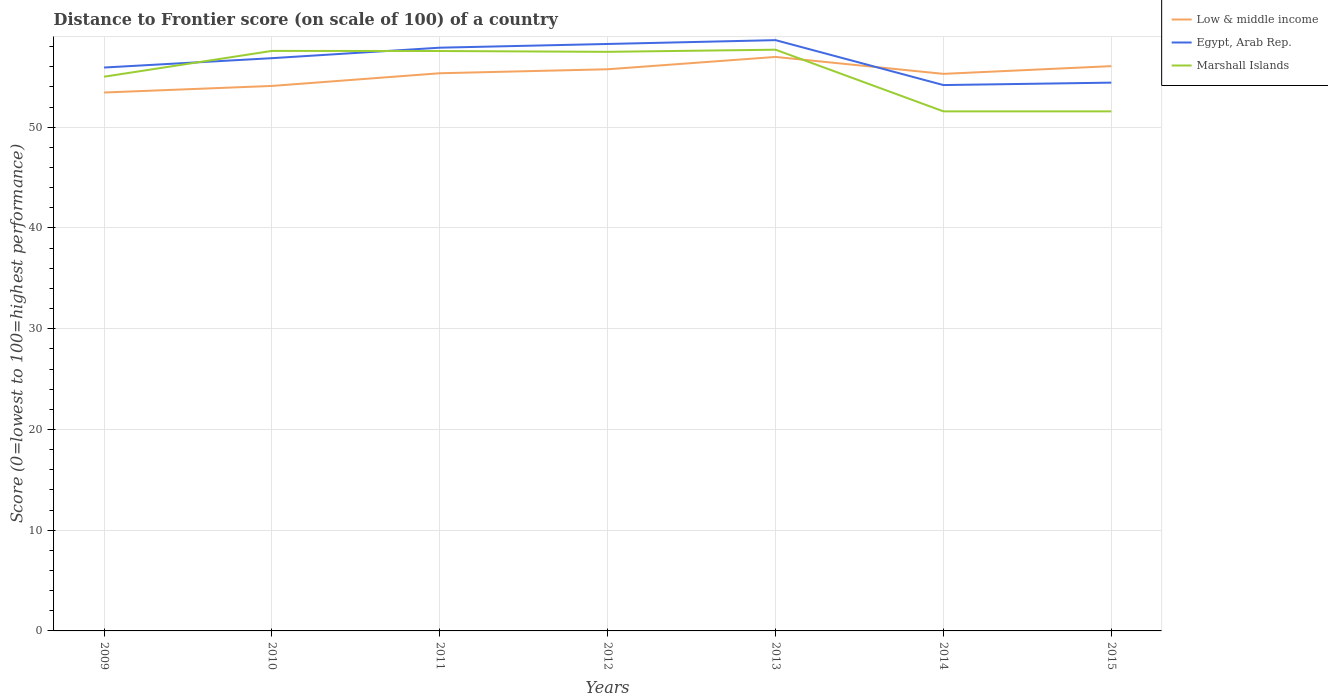Does the line corresponding to Marshall Islands intersect with the line corresponding to Low & middle income?
Keep it short and to the point. Yes. Is the number of lines equal to the number of legend labels?
Ensure brevity in your answer.  Yes. Across all years, what is the maximum distance to frontier score of in Marshall Islands?
Your response must be concise. 51.58. What is the difference between the highest and the second highest distance to frontier score of in Egypt, Arab Rep.?
Keep it short and to the point. 4.46. What is the difference between the highest and the lowest distance to frontier score of in Low & middle income?
Keep it short and to the point. 5. How many lines are there?
Provide a short and direct response. 3. What is the difference between two consecutive major ticks on the Y-axis?
Give a very brief answer. 10. Are the values on the major ticks of Y-axis written in scientific E-notation?
Your answer should be compact. No. Does the graph contain grids?
Ensure brevity in your answer.  Yes. How many legend labels are there?
Your response must be concise. 3. How are the legend labels stacked?
Your answer should be compact. Vertical. What is the title of the graph?
Offer a very short reply. Distance to Frontier score (on scale of 100) of a country. Does "Other small states" appear as one of the legend labels in the graph?
Offer a terse response. No. What is the label or title of the X-axis?
Give a very brief answer. Years. What is the label or title of the Y-axis?
Offer a very short reply. Score (0=lowest to 100=highest performance). What is the Score (0=lowest to 100=highest performance) in Low & middle income in 2009?
Ensure brevity in your answer.  53.45. What is the Score (0=lowest to 100=highest performance) of Egypt, Arab Rep. in 2009?
Your answer should be compact. 55.93. What is the Score (0=lowest to 100=highest performance) of Marshall Islands in 2009?
Ensure brevity in your answer.  55.02. What is the Score (0=lowest to 100=highest performance) of Low & middle income in 2010?
Your answer should be compact. 54.1. What is the Score (0=lowest to 100=highest performance) of Egypt, Arab Rep. in 2010?
Offer a terse response. 56.86. What is the Score (0=lowest to 100=highest performance) in Marshall Islands in 2010?
Offer a very short reply. 57.58. What is the Score (0=lowest to 100=highest performance) of Low & middle income in 2011?
Give a very brief answer. 55.36. What is the Score (0=lowest to 100=highest performance) in Egypt, Arab Rep. in 2011?
Make the answer very short. 57.9. What is the Score (0=lowest to 100=highest performance) in Marshall Islands in 2011?
Ensure brevity in your answer.  57.57. What is the Score (0=lowest to 100=highest performance) in Low & middle income in 2012?
Your response must be concise. 55.76. What is the Score (0=lowest to 100=highest performance) of Egypt, Arab Rep. in 2012?
Ensure brevity in your answer.  58.27. What is the Score (0=lowest to 100=highest performance) of Marshall Islands in 2012?
Offer a very short reply. 57.49. What is the Score (0=lowest to 100=highest performance) in Low & middle income in 2013?
Your answer should be compact. 56.98. What is the Score (0=lowest to 100=highest performance) of Egypt, Arab Rep. in 2013?
Offer a terse response. 58.65. What is the Score (0=lowest to 100=highest performance) in Marshall Islands in 2013?
Give a very brief answer. 57.7. What is the Score (0=lowest to 100=highest performance) in Low & middle income in 2014?
Your answer should be very brief. 55.3. What is the Score (0=lowest to 100=highest performance) in Egypt, Arab Rep. in 2014?
Provide a short and direct response. 54.19. What is the Score (0=lowest to 100=highest performance) of Marshall Islands in 2014?
Offer a terse response. 51.58. What is the Score (0=lowest to 100=highest performance) of Low & middle income in 2015?
Make the answer very short. 56.07. What is the Score (0=lowest to 100=highest performance) of Egypt, Arab Rep. in 2015?
Your answer should be compact. 54.43. What is the Score (0=lowest to 100=highest performance) in Marshall Islands in 2015?
Ensure brevity in your answer.  51.58. Across all years, what is the maximum Score (0=lowest to 100=highest performance) of Low & middle income?
Offer a terse response. 56.98. Across all years, what is the maximum Score (0=lowest to 100=highest performance) in Egypt, Arab Rep.?
Your response must be concise. 58.65. Across all years, what is the maximum Score (0=lowest to 100=highest performance) of Marshall Islands?
Make the answer very short. 57.7. Across all years, what is the minimum Score (0=lowest to 100=highest performance) of Low & middle income?
Keep it short and to the point. 53.45. Across all years, what is the minimum Score (0=lowest to 100=highest performance) in Egypt, Arab Rep.?
Make the answer very short. 54.19. Across all years, what is the minimum Score (0=lowest to 100=highest performance) in Marshall Islands?
Your answer should be very brief. 51.58. What is the total Score (0=lowest to 100=highest performance) in Low & middle income in the graph?
Give a very brief answer. 387.03. What is the total Score (0=lowest to 100=highest performance) in Egypt, Arab Rep. in the graph?
Your answer should be compact. 396.23. What is the total Score (0=lowest to 100=highest performance) of Marshall Islands in the graph?
Provide a short and direct response. 388.52. What is the difference between the Score (0=lowest to 100=highest performance) of Low & middle income in 2009 and that in 2010?
Make the answer very short. -0.65. What is the difference between the Score (0=lowest to 100=highest performance) of Egypt, Arab Rep. in 2009 and that in 2010?
Provide a succinct answer. -0.93. What is the difference between the Score (0=lowest to 100=highest performance) of Marshall Islands in 2009 and that in 2010?
Make the answer very short. -2.56. What is the difference between the Score (0=lowest to 100=highest performance) in Low & middle income in 2009 and that in 2011?
Give a very brief answer. -1.91. What is the difference between the Score (0=lowest to 100=highest performance) in Egypt, Arab Rep. in 2009 and that in 2011?
Offer a terse response. -1.97. What is the difference between the Score (0=lowest to 100=highest performance) in Marshall Islands in 2009 and that in 2011?
Make the answer very short. -2.55. What is the difference between the Score (0=lowest to 100=highest performance) in Low & middle income in 2009 and that in 2012?
Your response must be concise. -2.31. What is the difference between the Score (0=lowest to 100=highest performance) of Egypt, Arab Rep. in 2009 and that in 2012?
Offer a terse response. -2.34. What is the difference between the Score (0=lowest to 100=highest performance) in Marshall Islands in 2009 and that in 2012?
Your response must be concise. -2.47. What is the difference between the Score (0=lowest to 100=highest performance) of Low & middle income in 2009 and that in 2013?
Provide a short and direct response. -3.53. What is the difference between the Score (0=lowest to 100=highest performance) of Egypt, Arab Rep. in 2009 and that in 2013?
Keep it short and to the point. -2.72. What is the difference between the Score (0=lowest to 100=highest performance) in Marshall Islands in 2009 and that in 2013?
Your response must be concise. -2.68. What is the difference between the Score (0=lowest to 100=highest performance) of Low & middle income in 2009 and that in 2014?
Make the answer very short. -1.85. What is the difference between the Score (0=lowest to 100=highest performance) of Egypt, Arab Rep. in 2009 and that in 2014?
Your answer should be compact. 1.74. What is the difference between the Score (0=lowest to 100=highest performance) of Marshall Islands in 2009 and that in 2014?
Keep it short and to the point. 3.44. What is the difference between the Score (0=lowest to 100=highest performance) in Low & middle income in 2009 and that in 2015?
Ensure brevity in your answer.  -2.62. What is the difference between the Score (0=lowest to 100=highest performance) of Egypt, Arab Rep. in 2009 and that in 2015?
Your answer should be compact. 1.5. What is the difference between the Score (0=lowest to 100=highest performance) in Marshall Islands in 2009 and that in 2015?
Offer a very short reply. 3.44. What is the difference between the Score (0=lowest to 100=highest performance) of Low & middle income in 2010 and that in 2011?
Provide a short and direct response. -1.26. What is the difference between the Score (0=lowest to 100=highest performance) in Egypt, Arab Rep. in 2010 and that in 2011?
Make the answer very short. -1.04. What is the difference between the Score (0=lowest to 100=highest performance) in Low & middle income in 2010 and that in 2012?
Ensure brevity in your answer.  -1.65. What is the difference between the Score (0=lowest to 100=highest performance) of Egypt, Arab Rep. in 2010 and that in 2012?
Provide a short and direct response. -1.41. What is the difference between the Score (0=lowest to 100=highest performance) of Marshall Islands in 2010 and that in 2012?
Offer a terse response. 0.09. What is the difference between the Score (0=lowest to 100=highest performance) of Low & middle income in 2010 and that in 2013?
Give a very brief answer. -2.88. What is the difference between the Score (0=lowest to 100=highest performance) in Egypt, Arab Rep. in 2010 and that in 2013?
Provide a short and direct response. -1.79. What is the difference between the Score (0=lowest to 100=highest performance) in Marshall Islands in 2010 and that in 2013?
Your answer should be very brief. -0.12. What is the difference between the Score (0=lowest to 100=highest performance) of Low & middle income in 2010 and that in 2014?
Your response must be concise. -1.2. What is the difference between the Score (0=lowest to 100=highest performance) in Egypt, Arab Rep. in 2010 and that in 2014?
Make the answer very short. 2.67. What is the difference between the Score (0=lowest to 100=highest performance) in Low & middle income in 2010 and that in 2015?
Provide a short and direct response. -1.97. What is the difference between the Score (0=lowest to 100=highest performance) in Egypt, Arab Rep. in 2010 and that in 2015?
Ensure brevity in your answer.  2.43. What is the difference between the Score (0=lowest to 100=highest performance) in Low & middle income in 2011 and that in 2012?
Give a very brief answer. -0.4. What is the difference between the Score (0=lowest to 100=highest performance) of Egypt, Arab Rep. in 2011 and that in 2012?
Your answer should be very brief. -0.37. What is the difference between the Score (0=lowest to 100=highest performance) in Low & middle income in 2011 and that in 2013?
Offer a very short reply. -1.62. What is the difference between the Score (0=lowest to 100=highest performance) in Egypt, Arab Rep. in 2011 and that in 2013?
Provide a succinct answer. -0.75. What is the difference between the Score (0=lowest to 100=highest performance) of Marshall Islands in 2011 and that in 2013?
Offer a terse response. -0.13. What is the difference between the Score (0=lowest to 100=highest performance) of Low & middle income in 2011 and that in 2014?
Your answer should be compact. 0.06. What is the difference between the Score (0=lowest to 100=highest performance) of Egypt, Arab Rep. in 2011 and that in 2014?
Offer a terse response. 3.71. What is the difference between the Score (0=lowest to 100=highest performance) of Marshall Islands in 2011 and that in 2014?
Provide a succinct answer. 5.99. What is the difference between the Score (0=lowest to 100=highest performance) in Low & middle income in 2011 and that in 2015?
Your response must be concise. -0.71. What is the difference between the Score (0=lowest to 100=highest performance) of Egypt, Arab Rep. in 2011 and that in 2015?
Provide a succinct answer. 3.47. What is the difference between the Score (0=lowest to 100=highest performance) of Marshall Islands in 2011 and that in 2015?
Offer a terse response. 5.99. What is the difference between the Score (0=lowest to 100=highest performance) in Low & middle income in 2012 and that in 2013?
Give a very brief answer. -1.23. What is the difference between the Score (0=lowest to 100=highest performance) in Egypt, Arab Rep. in 2012 and that in 2013?
Keep it short and to the point. -0.38. What is the difference between the Score (0=lowest to 100=highest performance) of Marshall Islands in 2012 and that in 2013?
Keep it short and to the point. -0.21. What is the difference between the Score (0=lowest to 100=highest performance) in Low & middle income in 2012 and that in 2014?
Provide a succinct answer. 0.46. What is the difference between the Score (0=lowest to 100=highest performance) in Egypt, Arab Rep. in 2012 and that in 2014?
Give a very brief answer. 4.08. What is the difference between the Score (0=lowest to 100=highest performance) in Marshall Islands in 2012 and that in 2014?
Your answer should be very brief. 5.91. What is the difference between the Score (0=lowest to 100=highest performance) in Low & middle income in 2012 and that in 2015?
Offer a very short reply. -0.31. What is the difference between the Score (0=lowest to 100=highest performance) of Egypt, Arab Rep. in 2012 and that in 2015?
Offer a very short reply. 3.84. What is the difference between the Score (0=lowest to 100=highest performance) of Marshall Islands in 2012 and that in 2015?
Give a very brief answer. 5.91. What is the difference between the Score (0=lowest to 100=highest performance) in Low & middle income in 2013 and that in 2014?
Make the answer very short. 1.68. What is the difference between the Score (0=lowest to 100=highest performance) in Egypt, Arab Rep. in 2013 and that in 2014?
Offer a very short reply. 4.46. What is the difference between the Score (0=lowest to 100=highest performance) of Marshall Islands in 2013 and that in 2014?
Keep it short and to the point. 6.12. What is the difference between the Score (0=lowest to 100=highest performance) of Low & middle income in 2013 and that in 2015?
Provide a short and direct response. 0.91. What is the difference between the Score (0=lowest to 100=highest performance) of Egypt, Arab Rep. in 2013 and that in 2015?
Your answer should be compact. 4.22. What is the difference between the Score (0=lowest to 100=highest performance) in Marshall Islands in 2013 and that in 2015?
Provide a short and direct response. 6.12. What is the difference between the Score (0=lowest to 100=highest performance) of Low & middle income in 2014 and that in 2015?
Give a very brief answer. -0.77. What is the difference between the Score (0=lowest to 100=highest performance) in Egypt, Arab Rep. in 2014 and that in 2015?
Give a very brief answer. -0.24. What is the difference between the Score (0=lowest to 100=highest performance) in Marshall Islands in 2014 and that in 2015?
Give a very brief answer. 0. What is the difference between the Score (0=lowest to 100=highest performance) of Low & middle income in 2009 and the Score (0=lowest to 100=highest performance) of Egypt, Arab Rep. in 2010?
Ensure brevity in your answer.  -3.41. What is the difference between the Score (0=lowest to 100=highest performance) in Low & middle income in 2009 and the Score (0=lowest to 100=highest performance) in Marshall Islands in 2010?
Provide a short and direct response. -4.13. What is the difference between the Score (0=lowest to 100=highest performance) of Egypt, Arab Rep. in 2009 and the Score (0=lowest to 100=highest performance) of Marshall Islands in 2010?
Your answer should be compact. -1.65. What is the difference between the Score (0=lowest to 100=highest performance) in Low & middle income in 2009 and the Score (0=lowest to 100=highest performance) in Egypt, Arab Rep. in 2011?
Ensure brevity in your answer.  -4.45. What is the difference between the Score (0=lowest to 100=highest performance) in Low & middle income in 2009 and the Score (0=lowest to 100=highest performance) in Marshall Islands in 2011?
Your answer should be compact. -4.12. What is the difference between the Score (0=lowest to 100=highest performance) of Egypt, Arab Rep. in 2009 and the Score (0=lowest to 100=highest performance) of Marshall Islands in 2011?
Offer a very short reply. -1.64. What is the difference between the Score (0=lowest to 100=highest performance) in Low & middle income in 2009 and the Score (0=lowest to 100=highest performance) in Egypt, Arab Rep. in 2012?
Ensure brevity in your answer.  -4.82. What is the difference between the Score (0=lowest to 100=highest performance) in Low & middle income in 2009 and the Score (0=lowest to 100=highest performance) in Marshall Islands in 2012?
Your answer should be compact. -4.04. What is the difference between the Score (0=lowest to 100=highest performance) of Egypt, Arab Rep. in 2009 and the Score (0=lowest to 100=highest performance) of Marshall Islands in 2012?
Provide a succinct answer. -1.56. What is the difference between the Score (0=lowest to 100=highest performance) of Low & middle income in 2009 and the Score (0=lowest to 100=highest performance) of Egypt, Arab Rep. in 2013?
Give a very brief answer. -5.2. What is the difference between the Score (0=lowest to 100=highest performance) in Low & middle income in 2009 and the Score (0=lowest to 100=highest performance) in Marshall Islands in 2013?
Offer a very short reply. -4.25. What is the difference between the Score (0=lowest to 100=highest performance) in Egypt, Arab Rep. in 2009 and the Score (0=lowest to 100=highest performance) in Marshall Islands in 2013?
Offer a very short reply. -1.77. What is the difference between the Score (0=lowest to 100=highest performance) in Low & middle income in 2009 and the Score (0=lowest to 100=highest performance) in Egypt, Arab Rep. in 2014?
Make the answer very short. -0.74. What is the difference between the Score (0=lowest to 100=highest performance) of Low & middle income in 2009 and the Score (0=lowest to 100=highest performance) of Marshall Islands in 2014?
Keep it short and to the point. 1.87. What is the difference between the Score (0=lowest to 100=highest performance) in Egypt, Arab Rep. in 2009 and the Score (0=lowest to 100=highest performance) in Marshall Islands in 2014?
Keep it short and to the point. 4.35. What is the difference between the Score (0=lowest to 100=highest performance) in Low & middle income in 2009 and the Score (0=lowest to 100=highest performance) in Egypt, Arab Rep. in 2015?
Provide a succinct answer. -0.98. What is the difference between the Score (0=lowest to 100=highest performance) in Low & middle income in 2009 and the Score (0=lowest to 100=highest performance) in Marshall Islands in 2015?
Your answer should be compact. 1.87. What is the difference between the Score (0=lowest to 100=highest performance) in Egypt, Arab Rep. in 2009 and the Score (0=lowest to 100=highest performance) in Marshall Islands in 2015?
Make the answer very short. 4.35. What is the difference between the Score (0=lowest to 100=highest performance) of Low & middle income in 2010 and the Score (0=lowest to 100=highest performance) of Egypt, Arab Rep. in 2011?
Ensure brevity in your answer.  -3.8. What is the difference between the Score (0=lowest to 100=highest performance) of Low & middle income in 2010 and the Score (0=lowest to 100=highest performance) of Marshall Islands in 2011?
Make the answer very short. -3.47. What is the difference between the Score (0=lowest to 100=highest performance) of Egypt, Arab Rep. in 2010 and the Score (0=lowest to 100=highest performance) of Marshall Islands in 2011?
Provide a succinct answer. -0.71. What is the difference between the Score (0=lowest to 100=highest performance) in Low & middle income in 2010 and the Score (0=lowest to 100=highest performance) in Egypt, Arab Rep. in 2012?
Give a very brief answer. -4.17. What is the difference between the Score (0=lowest to 100=highest performance) in Low & middle income in 2010 and the Score (0=lowest to 100=highest performance) in Marshall Islands in 2012?
Give a very brief answer. -3.39. What is the difference between the Score (0=lowest to 100=highest performance) in Egypt, Arab Rep. in 2010 and the Score (0=lowest to 100=highest performance) in Marshall Islands in 2012?
Ensure brevity in your answer.  -0.63. What is the difference between the Score (0=lowest to 100=highest performance) in Low & middle income in 2010 and the Score (0=lowest to 100=highest performance) in Egypt, Arab Rep. in 2013?
Your answer should be compact. -4.55. What is the difference between the Score (0=lowest to 100=highest performance) of Low & middle income in 2010 and the Score (0=lowest to 100=highest performance) of Marshall Islands in 2013?
Offer a terse response. -3.6. What is the difference between the Score (0=lowest to 100=highest performance) in Egypt, Arab Rep. in 2010 and the Score (0=lowest to 100=highest performance) in Marshall Islands in 2013?
Ensure brevity in your answer.  -0.84. What is the difference between the Score (0=lowest to 100=highest performance) in Low & middle income in 2010 and the Score (0=lowest to 100=highest performance) in Egypt, Arab Rep. in 2014?
Ensure brevity in your answer.  -0.09. What is the difference between the Score (0=lowest to 100=highest performance) in Low & middle income in 2010 and the Score (0=lowest to 100=highest performance) in Marshall Islands in 2014?
Keep it short and to the point. 2.52. What is the difference between the Score (0=lowest to 100=highest performance) in Egypt, Arab Rep. in 2010 and the Score (0=lowest to 100=highest performance) in Marshall Islands in 2014?
Offer a terse response. 5.28. What is the difference between the Score (0=lowest to 100=highest performance) of Low & middle income in 2010 and the Score (0=lowest to 100=highest performance) of Egypt, Arab Rep. in 2015?
Keep it short and to the point. -0.33. What is the difference between the Score (0=lowest to 100=highest performance) in Low & middle income in 2010 and the Score (0=lowest to 100=highest performance) in Marshall Islands in 2015?
Your answer should be very brief. 2.52. What is the difference between the Score (0=lowest to 100=highest performance) of Egypt, Arab Rep. in 2010 and the Score (0=lowest to 100=highest performance) of Marshall Islands in 2015?
Offer a very short reply. 5.28. What is the difference between the Score (0=lowest to 100=highest performance) in Low & middle income in 2011 and the Score (0=lowest to 100=highest performance) in Egypt, Arab Rep. in 2012?
Make the answer very short. -2.91. What is the difference between the Score (0=lowest to 100=highest performance) in Low & middle income in 2011 and the Score (0=lowest to 100=highest performance) in Marshall Islands in 2012?
Offer a very short reply. -2.13. What is the difference between the Score (0=lowest to 100=highest performance) in Egypt, Arab Rep. in 2011 and the Score (0=lowest to 100=highest performance) in Marshall Islands in 2012?
Make the answer very short. 0.41. What is the difference between the Score (0=lowest to 100=highest performance) in Low & middle income in 2011 and the Score (0=lowest to 100=highest performance) in Egypt, Arab Rep. in 2013?
Your answer should be compact. -3.29. What is the difference between the Score (0=lowest to 100=highest performance) of Low & middle income in 2011 and the Score (0=lowest to 100=highest performance) of Marshall Islands in 2013?
Provide a short and direct response. -2.34. What is the difference between the Score (0=lowest to 100=highest performance) of Low & middle income in 2011 and the Score (0=lowest to 100=highest performance) of Egypt, Arab Rep. in 2014?
Your answer should be compact. 1.17. What is the difference between the Score (0=lowest to 100=highest performance) in Low & middle income in 2011 and the Score (0=lowest to 100=highest performance) in Marshall Islands in 2014?
Keep it short and to the point. 3.78. What is the difference between the Score (0=lowest to 100=highest performance) of Egypt, Arab Rep. in 2011 and the Score (0=lowest to 100=highest performance) of Marshall Islands in 2014?
Provide a short and direct response. 6.32. What is the difference between the Score (0=lowest to 100=highest performance) of Low & middle income in 2011 and the Score (0=lowest to 100=highest performance) of Egypt, Arab Rep. in 2015?
Offer a terse response. 0.93. What is the difference between the Score (0=lowest to 100=highest performance) of Low & middle income in 2011 and the Score (0=lowest to 100=highest performance) of Marshall Islands in 2015?
Offer a very short reply. 3.78. What is the difference between the Score (0=lowest to 100=highest performance) in Egypt, Arab Rep. in 2011 and the Score (0=lowest to 100=highest performance) in Marshall Islands in 2015?
Your answer should be compact. 6.32. What is the difference between the Score (0=lowest to 100=highest performance) of Low & middle income in 2012 and the Score (0=lowest to 100=highest performance) of Egypt, Arab Rep. in 2013?
Your answer should be very brief. -2.89. What is the difference between the Score (0=lowest to 100=highest performance) of Low & middle income in 2012 and the Score (0=lowest to 100=highest performance) of Marshall Islands in 2013?
Your answer should be very brief. -1.94. What is the difference between the Score (0=lowest to 100=highest performance) of Egypt, Arab Rep. in 2012 and the Score (0=lowest to 100=highest performance) of Marshall Islands in 2013?
Give a very brief answer. 0.57. What is the difference between the Score (0=lowest to 100=highest performance) of Low & middle income in 2012 and the Score (0=lowest to 100=highest performance) of Egypt, Arab Rep. in 2014?
Provide a short and direct response. 1.57. What is the difference between the Score (0=lowest to 100=highest performance) in Low & middle income in 2012 and the Score (0=lowest to 100=highest performance) in Marshall Islands in 2014?
Keep it short and to the point. 4.18. What is the difference between the Score (0=lowest to 100=highest performance) of Egypt, Arab Rep. in 2012 and the Score (0=lowest to 100=highest performance) of Marshall Islands in 2014?
Provide a short and direct response. 6.69. What is the difference between the Score (0=lowest to 100=highest performance) of Low & middle income in 2012 and the Score (0=lowest to 100=highest performance) of Egypt, Arab Rep. in 2015?
Your answer should be compact. 1.33. What is the difference between the Score (0=lowest to 100=highest performance) in Low & middle income in 2012 and the Score (0=lowest to 100=highest performance) in Marshall Islands in 2015?
Ensure brevity in your answer.  4.18. What is the difference between the Score (0=lowest to 100=highest performance) in Egypt, Arab Rep. in 2012 and the Score (0=lowest to 100=highest performance) in Marshall Islands in 2015?
Your answer should be compact. 6.69. What is the difference between the Score (0=lowest to 100=highest performance) in Low & middle income in 2013 and the Score (0=lowest to 100=highest performance) in Egypt, Arab Rep. in 2014?
Make the answer very short. 2.79. What is the difference between the Score (0=lowest to 100=highest performance) of Low & middle income in 2013 and the Score (0=lowest to 100=highest performance) of Marshall Islands in 2014?
Provide a short and direct response. 5.4. What is the difference between the Score (0=lowest to 100=highest performance) of Egypt, Arab Rep. in 2013 and the Score (0=lowest to 100=highest performance) of Marshall Islands in 2014?
Provide a short and direct response. 7.07. What is the difference between the Score (0=lowest to 100=highest performance) of Low & middle income in 2013 and the Score (0=lowest to 100=highest performance) of Egypt, Arab Rep. in 2015?
Offer a very short reply. 2.55. What is the difference between the Score (0=lowest to 100=highest performance) in Low & middle income in 2013 and the Score (0=lowest to 100=highest performance) in Marshall Islands in 2015?
Provide a succinct answer. 5.4. What is the difference between the Score (0=lowest to 100=highest performance) in Egypt, Arab Rep. in 2013 and the Score (0=lowest to 100=highest performance) in Marshall Islands in 2015?
Your response must be concise. 7.07. What is the difference between the Score (0=lowest to 100=highest performance) of Low & middle income in 2014 and the Score (0=lowest to 100=highest performance) of Egypt, Arab Rep. in 2015?
Ensure brevity in your answer.  0.87. What is the difference between the Score (0=lowest to 100=highest performance) in Low & middle income in 2014 and the Score (0=lowest to 100=highest performance) in Marshall Islands in 2015?
Offer a very short reply. 3.72. What is the difference between the Score (0=lowest to 100=highest performance) of Egypt, Arab Rep. in 2014 and the Score (0=lowest to 100=highest performance) of Marshall Islands in 2015?
Make the answer very short. 2.61. What is the average Score (0=lowest to 100=highest performance) of Low & middle income per year?
Your response must be concise. 55.29. What is the average Score (0=lowest to 100=highest performance) in Egypt, Arab Rep. per year?
Keep it short and to the point. 56.6. What is the average Score (0=lowest to 100=highest performance) in Marshall Islands per year?
Your response must be concise. 55.5. In the year 2009, what is the difference between the Score (0=lowest to 100=highest performance) in Low & middle income and Score (0=lowest to 100=highest performance) in Egypt, Arab Rep.?
Ensure brevity in your answer.  -2.48. In the year 2009, what is the difference between the Score (0=lowest to 100=highest performance) in Low & middle income and Score (0=lowest to 100=highest performance) in Marshall Islands?
Ensure brevity in your answer.  -1.57. In the year 2009, what is the difference between the Score (0=lowest to 100=highest performance) of Egypt, Arab Rep. and Score (0=lowest to 100=highest performance) of Marshall Islands?
Your answer should be very brief. 0.91. In the year 2010, what is the difference between the Score (0=lowest to 100=highest performance) of Low & middle income and Score (0=lowest to 100=highest performance) of Egypt, Arab Rep.?
Make the answer very short. -2.76. In the year 2010, what is the difference between the Score (0=lowest to 100=highest performance) in Low & middle income and Score (0=lowest to 100=highest performance) in Marshall Islands?
Provide a succinct answer. -3.48. In the year 2010, what is the difference between the Score (0=lowest to 100=highest performance) of Egypt, Arab Rep. and Score (0=lowest to 100=highest performance) of Marshall Islands?
Provide a short and direct response. -0.72. In the year 2011, what is the difference between the Score (0=lowest to 100=highest performance) in Low & middle income and Score (0=lowest to 100=highest performance) in Egypt, Arab Rep.?
Provide a short and direct response. -2.54. In the year 2011, what is the difference between the Score (0=lowest to 100=highest performance) of Low & middle income and Score (0=lowest to 100=highest performance) of Marshall Islands?
Provide a succinct answer. -2.21. In the year 2011, what is the difference between the Score (0=lowest to 100=highest performance) of Egypt, Arab Rep. and Score (0=lowest to 100=highest performance) of Marshall Islands?
Provide a short and direct response. 0.33. In the year 2012, what is the difference between the Score (0=lowest to 100=highest performance) in Low & middle income and Score (0=lowest to 100=highest performance) in Egypt, Arab Rep.?
Provide a succinct answer. -2.51. In the year 2012, what is the difference between the Score (0=lowest to 100=highest performance) in Low & middle income and Score (0=lowest to 100=highest performance) in Marshall Islands?
Offer a very short reply. -1.73. In the year 2012, what is the difference between the Score (0=lowest to 100=highest performance) of Egypt, Arab Rep. and Score (0=lowest to 100=highest performance) of Marshall Islands?
Ensure brevity in your answer.  0.78. In the year 2013, what is the difference between the Score (0=lowest to 100=highest performance) in Low & middle income and Score (0=lowest to 100=highest performance) in Egypt, Arab Rep.?
Ensure brevity in your answer.  -1.67. In the year 2013, what is the difference between the Score (0=lowest to 100=highest performance) of Low & middle income and Score (0=lowest to 100=highest performance) of Marshall Islands?
Your response must be concise. -0.72. In the year 2014, what is the difference between the Score (0=lowest to 100=highest performance) of Low & middle income and Score (0=lowest to 100=highest performance) of Egypt, Arab Rep.?
Your answer should be compact. 1.11. In the year 2014, what is the difference between the Score (0=lowest to 100=highest performance) of Low & middle income and Score (0=lowest to 100=highest performance) of Marshall Islands?
Provide a short and direct response. 3.72. In the year 2014, what is the difference between the Score (0=lowest to 100=highest performance) of Egypt, Arab Rep. and Score (0=lowest to 100=highest performance) of Marshall Islands?
Your answer should be very brief. 2.61. In the year 2015, what is the difference between the Score (0=lowest to 100=highest performance) in Low & middle income and Score (0=lowest to 100=highest performance) in Egypt, Arab Rep.?
Make the answer very short. 1.64. In the year 2015, what is the difference between the Score (0=lowest to 100=highest performance) of Low & middle income and Score (0=lowest to 100=highest performance) of Marshall Islands?
Your answer should be very brief. 4.49. In the year 2015, what is the difference between the Score (0=lowest to 100=highest performance) of Egypt, Arab Rep. and Score (0=lowest to 100=highest performance) of Marshall Islands?
Give a very brief answer. 2.85. What is the ratio of the Score (0=lowest to 100=highest performance) in Low & middle income in 2009 to that in 2010?
Your response must be concise. 0.99. What is the ratio of the Score (0=lowest to 100=highest performance) of Egypt, Arab Rep. in 2009 to that in 2010?
Give a very brief answer. 0.98. What is the ratio of the Score (0=lowest to 100=highest performance) of Marshall Islands in 2009 to that in 2010?
Your answer should be very brief. 0.96. What is the ratio of the Score (0=lowest to 100=highest performance) of Low & middle income in 2009 to that in 2011?
Give a very brief answer. 0.97. What is the ratio of the Score (0=lowest to 100=highest performance) of Marshall Islands in 2009 to that in 2011?
Provide a short and direct response. 0.96. What is the ratio of the Score (0=lowest to 100=highest performance) of Low & middle income in 2009 to that in 2012?
Provide a short and direct response. 0.96. What is the ratio of the Score (0=lowest to 100=highest performance) in Egypt, Arab Rep. in 2009 to that in 2012?
Keep it short and to the point. 0.96. What is the ratio of the Score (0=lowest to 100=highest performance) of Marshall Islands in 2009 to that in 2012?
Provide a short and direct response. 0.96. What is the ratio of the Score (0=lowest to 100=highest performance) of Low & middle income in 2009 to that in 2013?
Ensure brevity in your answer.  0.94. What is the ratio of the Score (0=lowest to 100=highest performance) of Egypt, Arab Rep. in 2009 to that in 2013?
Offer a very short reply. 0.95. What is the ratio of the Score (0=lowest to 100=highest performance) in Marshall Islands in 2009 to that in 2013?
Make the answer very short. 0.95. What is the ratio of the Score (0=lowest to 100=highest performance) in Low & middle income in 2009 to that in 2014?
Offer a terse response. 0.97. What is the ratio of the Score (0=lowest to 100=highest performance) in Egypt, Arab Rep. in 2009 to that in 2014?
Provide a short and direct response. 1.03. What is the ratio of the Score (0=lowest to 100=highest performance) in Marshall Islands in 2009 to that in 2014?
Offer a very short reply. 1.07. What is the ratio of the Score (0=lowest to 100=highest performance) in Low & middle income in 2009 to that in 2015?
Keep it short and to the point. 0.95. What is the ratio of the Score (0=lowest to 100=highest performance) in Egypt, Arab Rep. in 2009 to that in 2015?
Keep it short and to the point. 1.03. What is the ratio of the Score (0=lowest to 100=highest performance) of Marshall Islands in 2009 to that in 2015?
Your answer should be compact. 1.07. What is the ratio of the Score (0=lowest to 100=highest performance) in Low & middle income in 2010 to that in 2011?
Offer a terse response. 0.98. What is the ratio of the Score (0=lowest to 100=highest performance) in Egypt, Arab Rep. in 2010 to that in 2011?
Keep it short and to the point. 0.98. What is the ratio of the Score (0=lowest to 100=highest performance) in Marshall Islands in 2010 to that in 2011?
Keep it short and to the point. 1. What is the ratio of the Score (0=lowest to 100=highest performance) of Low & middle income in 2010 to that in 2012?
Offer a very short reply. 0.97. What is the ratio of the Score (0=lowest to 100=highest performance) in Egypt, Arab Rep. in 2010 to that in 2012?
Your response must be concise. 0.98. What is the ratio of the Score (0=lowest to 100=highest performance) of Low & middle income in 2010 to that in 2013?
Give a very brief answer. 0.95. What is the ratio of the Score (0=lowest to 100=highest performance) in Egypt, Arab Rep. in 2010 to that in 2013?
Provide a short and direct response. 0.97. What is the ratio of the Score (0=lowest to 100=highest performance) in Low & middle income in 2010 to that in 2014?
Keep it short and to the point. 0.98. What is the ratio of the Score (0=lowest to 100=highest performance) in Egypt, Arab Rep. in 2010 to that in 2014?
Provide a succinct answer. 1.05. What is the ratio of the Score (0=lowest to 100=highest performance) of Marshall Islands in 2010 to that in 2014?
Make the answer very short. 1.12. What is the ratio of the Score (0=lowest to 100=highest performance) of Low & middle income in 2010 to that in 2015?
Ensure brevity in your answer.  0.96. What is the ratio of the Score (0=lowest to 100=highest performance) of Egypt, Arab Rep. in 2010 to that in 2015?
Provide a succinct answer. 1.04. What is the ratio of the Score (0=lowest to 100=highest performance) of Marshall Islands in 2010 to that in 2015?
Ensure brevity in your answer.  1.12. What is the ratio of the Score (0=lowest to 100=highest performance) in Low & middle income in 2011 to that in 2012?
Ensure brevity in your answer.  0.99. What is the ratio of the Score (0=lowest to 100=highest performance) in Low & middle income in 2011 to that in 2013?
Your answer should be very brief. 0.97. What is the ratio of the Score (0=lowest to 100=highest performance) in Egypt, Arab Rep. in 2011 to that in 2013?
Your response must be concise. 0.99. What is the ratio of the Score (0=lowest to 100=highest performance) of Marshall Islands in 2011 to that in 2013?
Provide a short and direct response. 1. What is the ratio of the Score (0=lowest to 100=highest performance) of Egypt, Arab Rep. in 2011 to that in 2014?
Keep it short and to the point. 1.07. What is the ratio of the Score (0=lowest to 100=highest performance) in Marshall Islands in 2011 to that in 2014?
Your answer should be compact. 1.12. What is the ratio of the Score (0=lowest to 100=highest performance) in Low & middle income in 2011 to that in 2015?
Your answer should be compact. 0.99. What is the ratio of the Score (0=lowest to 100=highest performance) in Egypt, Arab Rep. in 2011 to that in 2015?
Provide a short and direct response. 1.06. What is the ratio of the Score (0=lowest to 100=highest performance) of Marshall Islands in 2011 to that in 2015?
Provide a short and direct response. 1.12. What is the ratio of the Score (0=lowest to 100=highest performance) in Low & middle income in 2012 to that in 2013?
Ensure brevity in your answer.  0.98. What is the ratio of the Score (0=lowest to 100=highest performance) in Egypt, Arab Rep. in 2012 to that in 2013?
Offer a very short reply. 0.99. What is the ratio of the Score (0=lowest to 100=highest performance) of Marshall Islands in 2012 to that in 2013?
Ensure brevity in your answer.  1. What is the ratio of the Score (0=lowest to 100=highest performance) in Low & middle income in 2012 to that in 2014?
Make the answer very short. 1.01. What is the ratio of the Score (0=lowest to 100=highest performance) of Egypt, Arab Rep. in 2012 to that in 2014?
Keep it short and to the point. 1.08. What is the ratio of the Score (0=lowest to 100=highest performance) in Marshall Islands in 2012 to that in 2014?
Offer a very short reply. 1.11. What is the ratio of the Score (0=lowest to 100=highest performance) of Low & middle income in 2012 to that in 2015?
Offer a very short reply. 0.99. What is the ratio of the Score (0=lowest to 100=highest performance) in Egypt, Arab Rep. in 2012 to that in 2015?
Keep it short and to the point. 1.07. What is the ratio of the Score (0=lowest to 100=highest performance) of Marshall Islands in 2012 to that in 2015?
Your answer should be very brief. 1.11. What is the ratio of the Score (0=lowest to 100=highest performance) in Low & middle income in 2013 to that in 2014?
Your response must be concise. 1.03. What is the ratio of the Score (0=lowest to 100=highest performance) of Egypt, Arab Rep. in 2013 to that in 2014?
Provide a short and direct response. 1.08. What is the ratio of the Score (0=lowest to 100=highest performance) of Marshall Islands in 2013 to that in 2014?
Give a very brief answer. 1.12. What is the ratio of the Score (0=lowest to 100=highest performance) in Low & middle income in 2013 to that in 2015?
Ensure brevity in your answer.  1.02. What is the ratio of the Score (0=lowest to 100=highest performance) of Egypt, Arab Rep. in 2013 to that in 2015?
Keep it short and to the point. 1.08. What is the ratio of the Score (0=lowest to 100=highest performance) in Marshall Islands in 2013 to that in 2015?
Ensure brevity in your answer.  1.12. What is the ratio of the Score (0=lowest to 100=highest performance) of Low & middle income in 2014 to that in 2015?
Give a very brief answer. 0.99. What is the ratio of the Score (0=lowest to 100=highest performance) of Egypt, Arab Rep. in 2014 to that in 2015?
Ensure brevity in your answer.  1. What is the difference between the highest and the second highest Score (0=lowest to 100=highest performance) in Low & middle income?
Give a very brief answer. 0.91. What is the difference between the highest and the second highest Score (0=lowest to 100=highest performance) of Egypt, Arab Rep.?
Ensure brevity in your answer.  0.38. What is the difference between the highest and the second highest Score (0=lowest to 100=highest performance) in Marshall Islands?
Your answer should be compact. 0.12. What is the difference between the highest and the lowest Score (0=lowest to 100=highest performance) in Low & middle income?
Your answer should be compact. 3.53. What is the difference between the highest and the lowest Score (0=lowest to 100=highest performance) in Egypt, Arab Rep.?
Give a very brief answer. 4.46. What is the difference between the highest and the lowest Score (0=lowest to 100=highest performance) of Marshall Islands?
Make the answer very short. 6.12. 